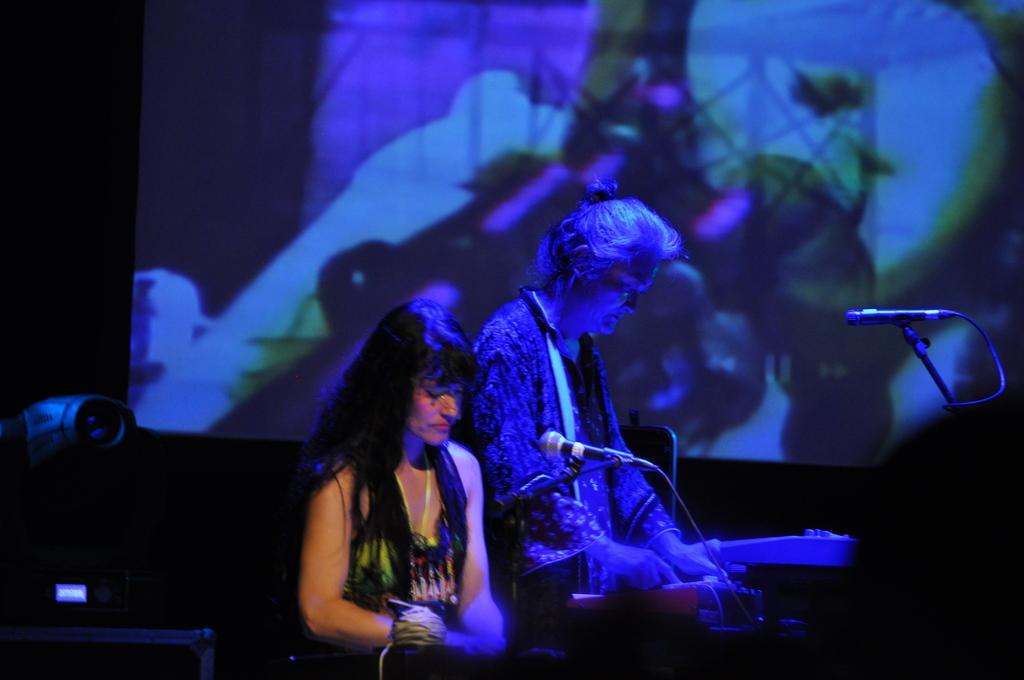Could you give a brief overview of what you see in this image? In this picture I can see there is a woman sitting and playing the music instrument and there is a micro phone and there is another person standing here and there is a screen here in the backdrop. 